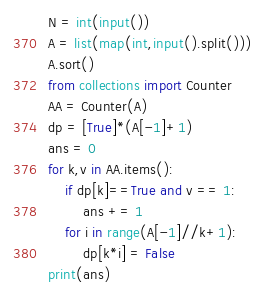Convert code to text. <code><loc_0><loc_0><loc_500><loc_500><_Python_>N = int(input())
A = list(map(int,input().split()))
A.sort()
from collections import Counter
AA = Counter(A)
dp = [True]*(A[-1]+1)
ans = 0
for k,v in AA.items():
    if dp[k]==True and v == 1:
        ans += 1
    for i in range(A[-1]//k+1):
        dp[k*i] = False
print(ans)</code> 